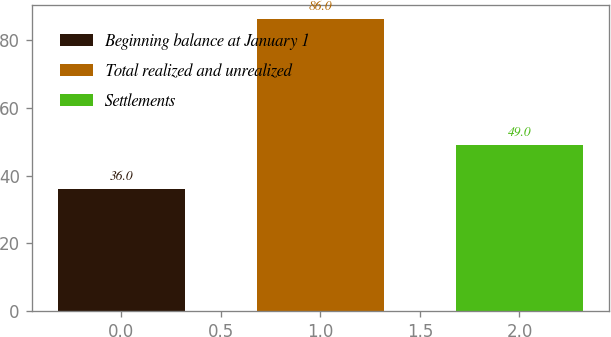<chart> <loc_0><loc_0><loc_500><loc_500><bar_chart><fcel>Beginning balance at January 1<fcel>Total realized and unrealized<fcel>Settlements<nl><fcel>36<fcel>86<fcel>49<nl></chart> 